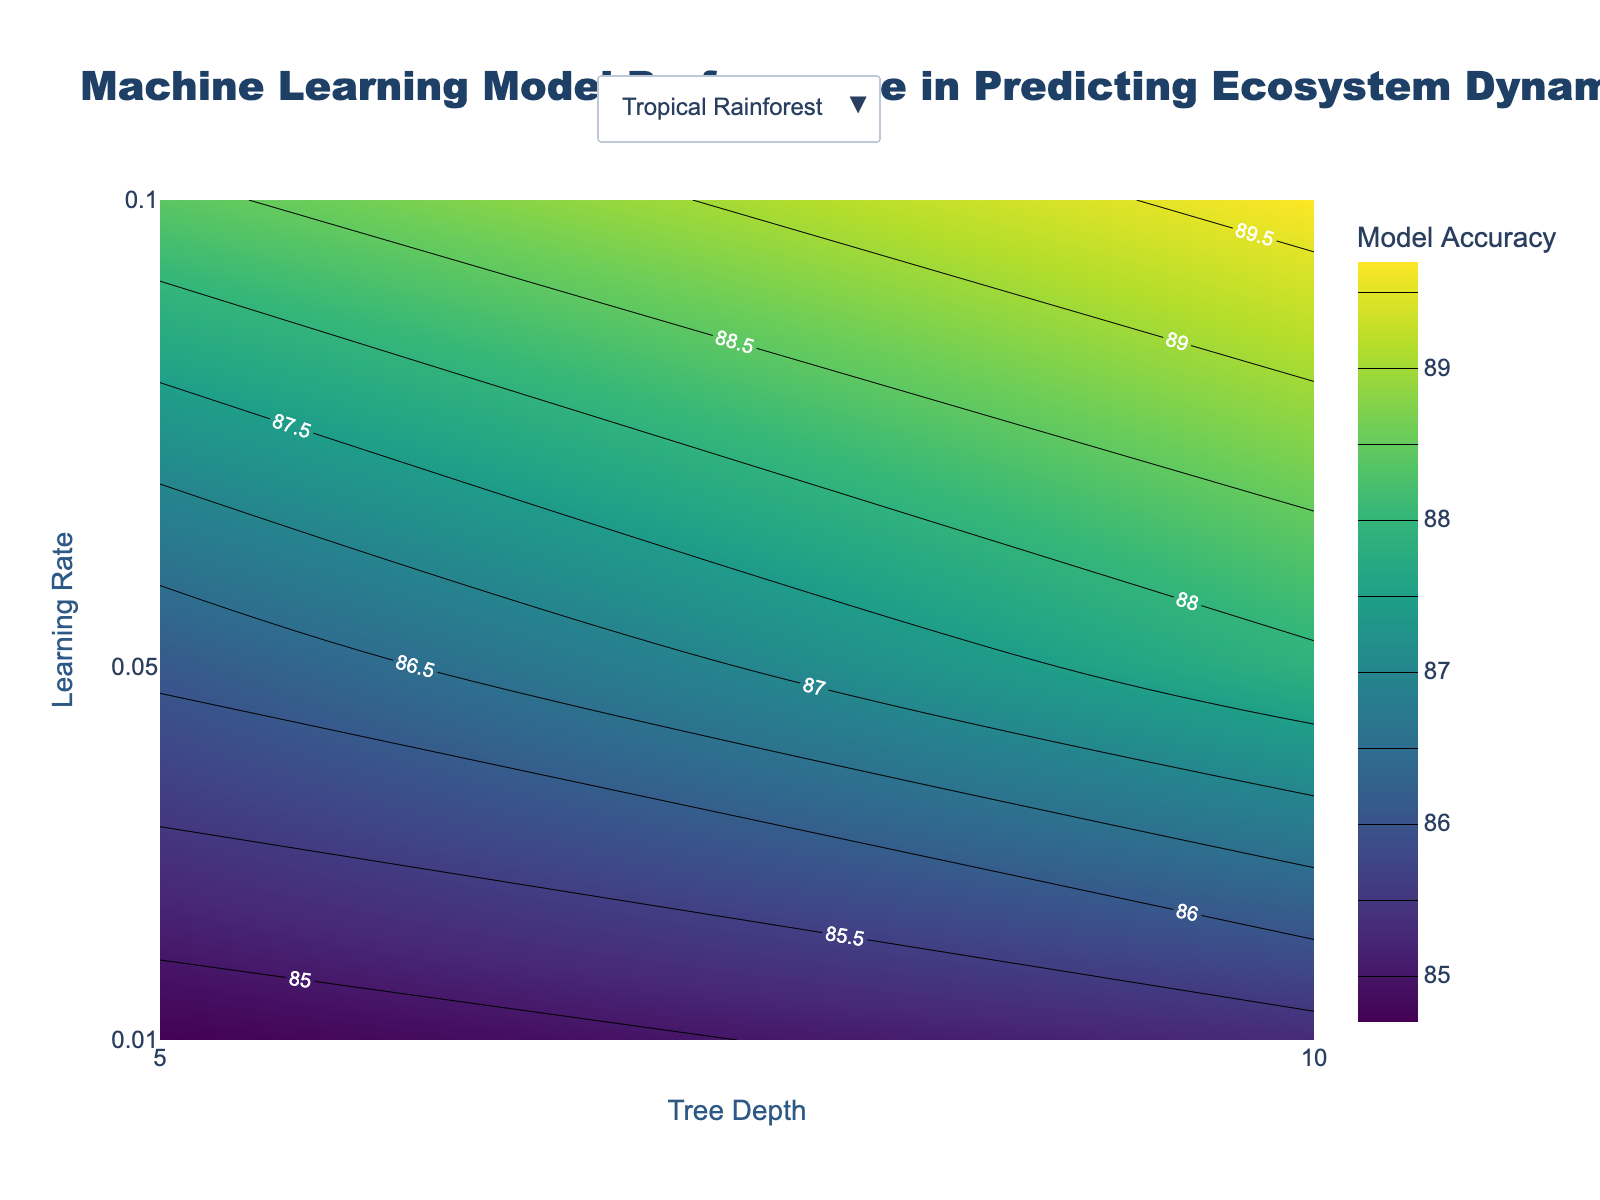What is the title of the plot? The title of the plot is typically positioned at the top of the chart and is written in a larger font size to draw attention. In this case, the title is formatted specifically with 'Machine Learning Model Performance in Predicting Ecosystem Dynamics'.
Answer: Machine Learning Model Performance in Predicting Ecosystem Dynamics What are the axes labels in this contour plot? Axes labels usually give clear indications of what each axis represents. For this plot, the x-axis represents 'Tree Depth' and the y-axis represents 'Learning Rate'.
Answer: Tree Depth (x-axis), Learning Rate (y-axis) Which ecosystem shows the highest model accuracy at a learning rate of 0.1 and a tree depth of 10? By examining the contour plot for each ecosystem (Tropical Rainforest, Savannah, Temperate Forest, Desert), we find that the Tropical Rainforest has the highest model accuracy at the specified hyperparameters.
Answer: Tropical Rainforest What is the overall trend in model accuracy as the learning rate increases for the Temperate Forest ecosystem? Observing the contour plot for the Temperate Forest, as the learning rate increases (moving up on the y-axis), the accuracy values also increase. This indicates a general positive trend.
Answer: Accuracy increases Compare the change in model accuracy between the Desert and Savannah ecosystems as tree depth increases from 5 to 10 at a learning rate of 0.05. For the Desert, at a learning rate of 0.05, the accuracy increases from 67.2 to 69.4 when the tree depth increases from 5 to 10. For the Savannah, at the same learning rate, the accuracy increases from 73.9 to 75.7.
Answer: Desert: 2.2, Savannah: 1.8 Which ecosystem has the least variance in model accuracy across different hyperparameters? Variance in accuracy can be judged by how spread out the accuracy values are in the contour plot. The Desert ecosystem shows relatively smaller differences in accuracy values across different hyperparameters compared to other ecosystems.
Answer: Desert What's the difference in model accuracy for the Savannah ecosystem at a learning rate of 0.01 versus 0.1, with a tree depth of 10? For a tree depth of 10, the Savannah ecosystem has model accuracies of 71.2 at a learning rate of 0.01, and 79.9 at a learning rate of 0.1. The difference is calculated as 79.9 - 71.2.
Answer: 8.7 For which tree depth does the Tropical Rainforest ecosystem show a larger increase in accuracy when the learning rate goes from 0.01 to 0.05? For a tree depth of 5, the accuracy increases from 84.7 to 86.1 (1.4). For a tree depth of 10, the accuracy increases from 85.3 to 87.9 (2.6), showing a larger increase at tree depth 10.
Answer: Tree Depth 10 At what learning rate does the Temperate Forest ecosystem first achieve an accuracy above 80%? Examining the contour plot for Temperate Forest, the accuracy first exceeds 80% at a learning rate of 0.05 with both tree depths reaching above this threshold.
Answer: 0.05 For the Desert ecosystem, how does the model's performance compare across tree depths at the lowest learning rate? At the lowest learning rate of 0.01, the accuracy for the Desert increases from 65.8 at tree depth 5 to 66.5 at tree depth 10.
Answer: 66.5 at tree depth 10 is higher 